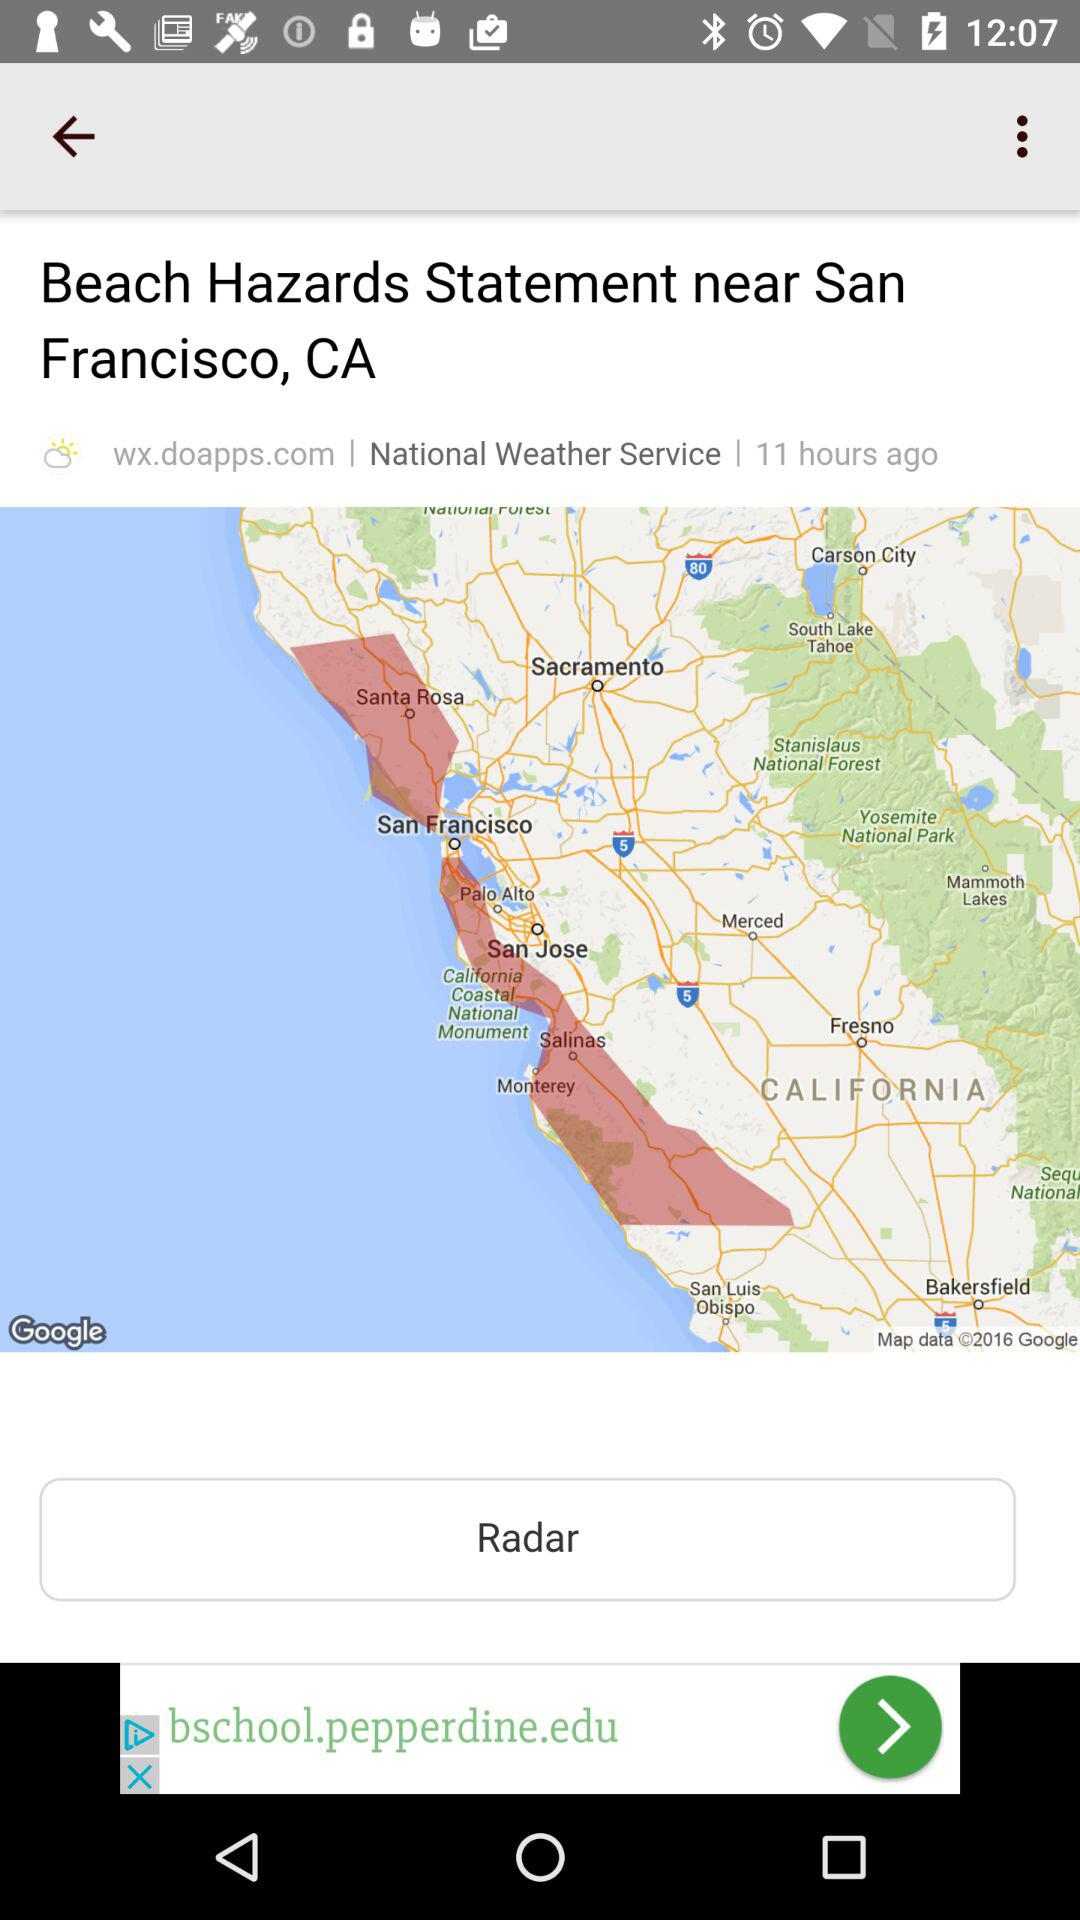How many hours ago was the statement issued?
Answer the question using a single word or phrase. 11 